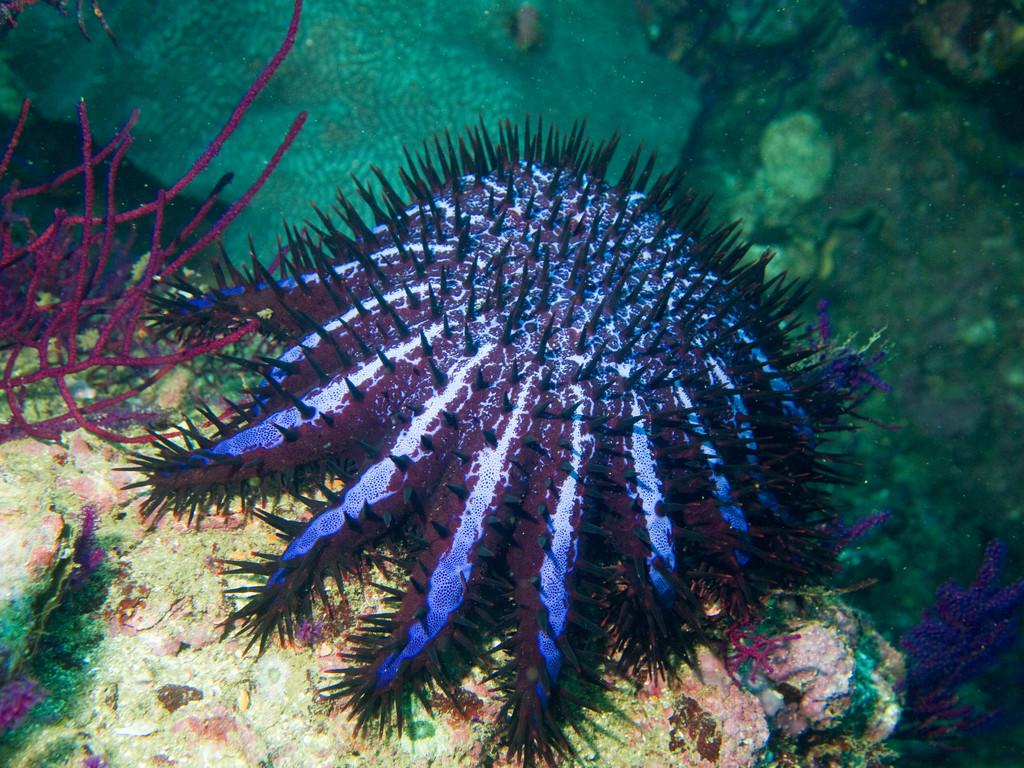What type of animal is in the image? There is a jellyfish in the image. Where is the jellyfish located? The jellyfish is in the water. Is the jellyfish delivering a parcel in the image? No, there is no parcel present in the image, and jellyfish do not have the ability to deliver parcels. 